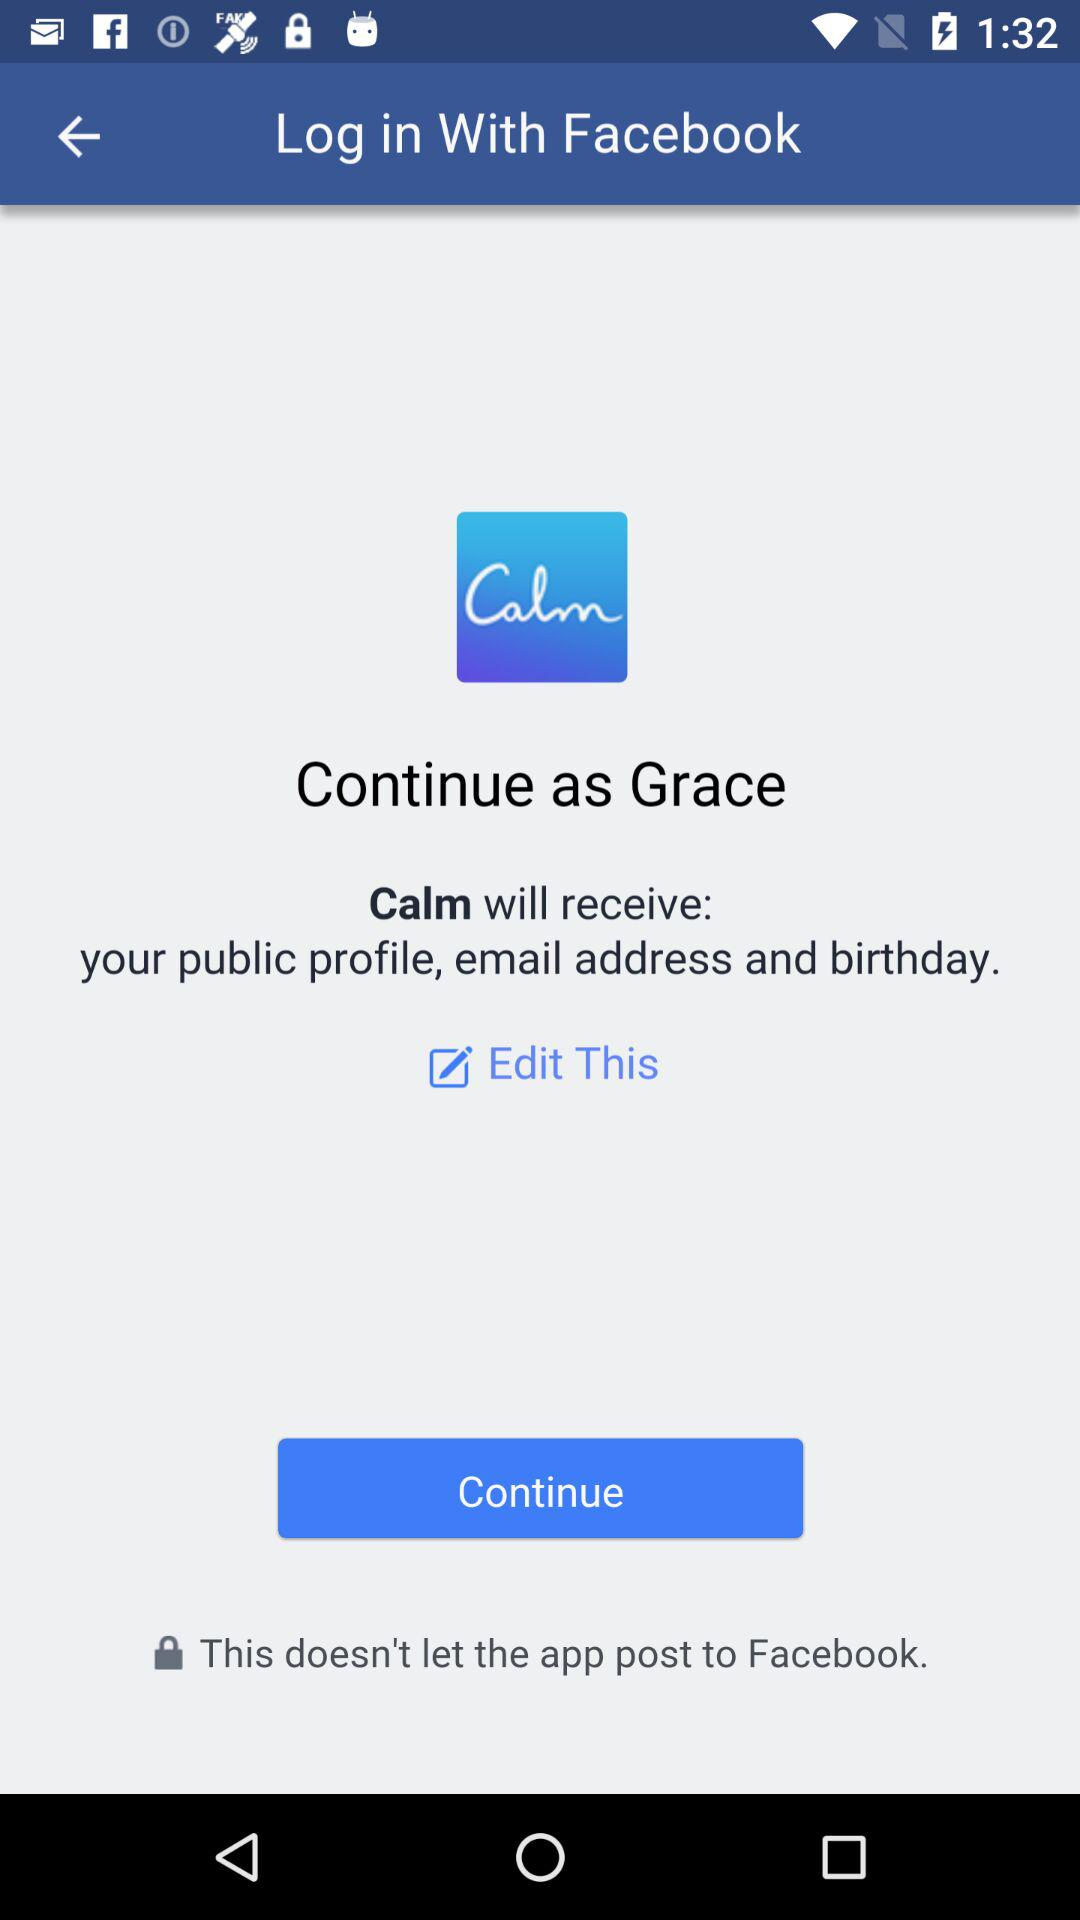Which information can we edit? You can edit your public profile, email address and birthday. 